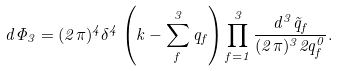<formula> <loc_0><loc_0><loc_500><loc_500>d { \Phi _ { 3 } } = ( 2 \pi ) ^ { 4 } \delta ^ { 4 } \left ( k - \sum _ { f } ^ { 3 } q _ { f } \right ) \prod _ { f = 1 } ^ { 3 } \frac { d ^ { 3 } { \vec { q } _ { f } } } { ( 2 \pi ) ^ { 3 } 2 q _ { f } ^ { 0 } } .</formula> 